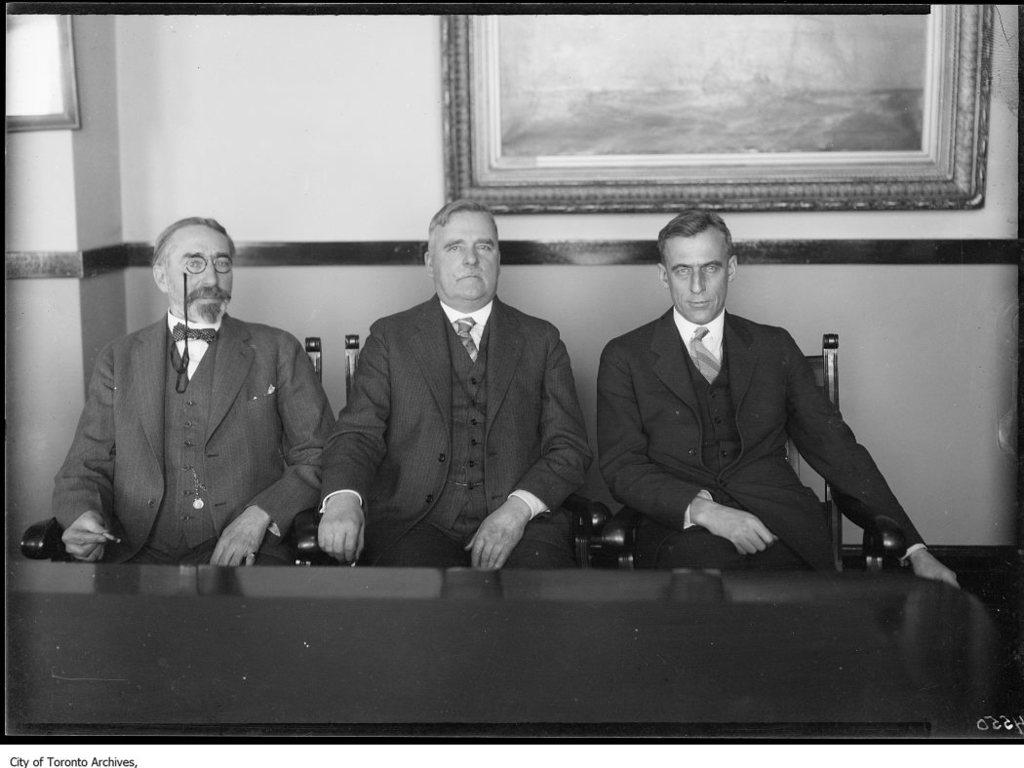How many men are in the image? There are three men in the image. What are the men wearing? Each man is wearing a blazer and a tie. What are the men doing in the image? The men are sitting on chairs. What is in front of the men? There is a table in front of the men. What can be seen in the background of the image? There is a wall with frames in the background. What type of activity are the men performing with the scissors in the image? There are no scissors present in the image, so no such activity can be observed. 